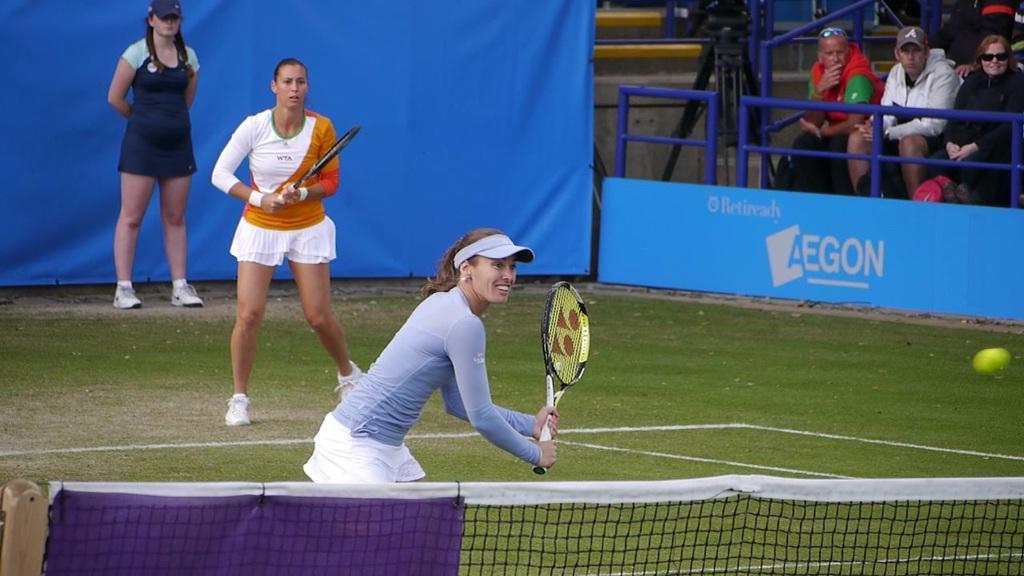Please provide a concise description of this image. I could see two players playing tennis in the court. In the back ground there is a blue banner and a lady standing and to the right corner there are some persons sitting and watching the match. 